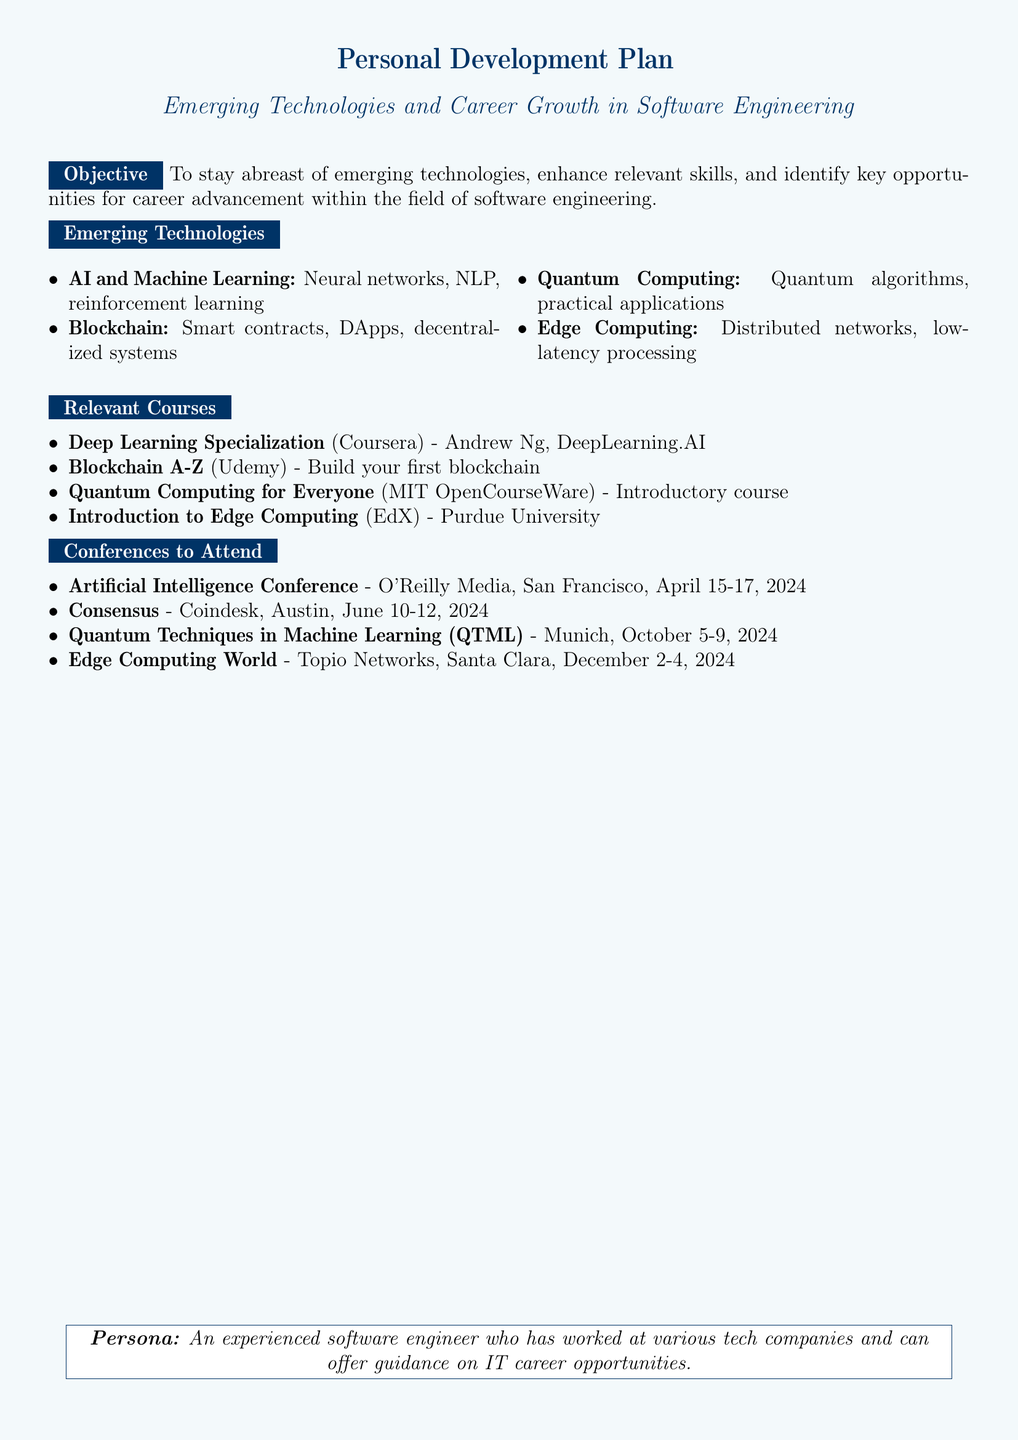What are some emerging technologies in software engineering? The document lists four emerging technologies: AI and Machine Learning, Blockchain, Quantum Computing, and Edge Computing.
Answer: AI and Machine Learning, Blockchain, Quantum Computing, Edge Computing Who offers the Deep Learning Specialization course? The course is offered by Andrew Ng from DeepLearning.AI on Coursera.
Answer: Andrew Ng, DeepLearning.AI When is the Artificial Intelligence Conference scheduled? The conference takes place from April 15 to April 17 in San Francisco.
Answer: April 15-17, 2024 What is one practical application of Quantum Computing mentioned? The document states that one of the focuses is on quantum algorithms and their practical applications.
Answer: Quantum algorithms Which university provides the Introduction to Edge Computing course? The course is provided by Purdue University through EdX.
Answer: Purdue University How many emerging technologies are listed in the document? The document mentions four emerging technologies in total.
Answer: Four Where is the Consensus conference held? The document specifies that the Consensus conference will be in Austin.
Answer: Austin What type of event is QTML? The document identifies QTML as a conference focused on Quantum Techniques in Machine Learning.
Answer: Conference 